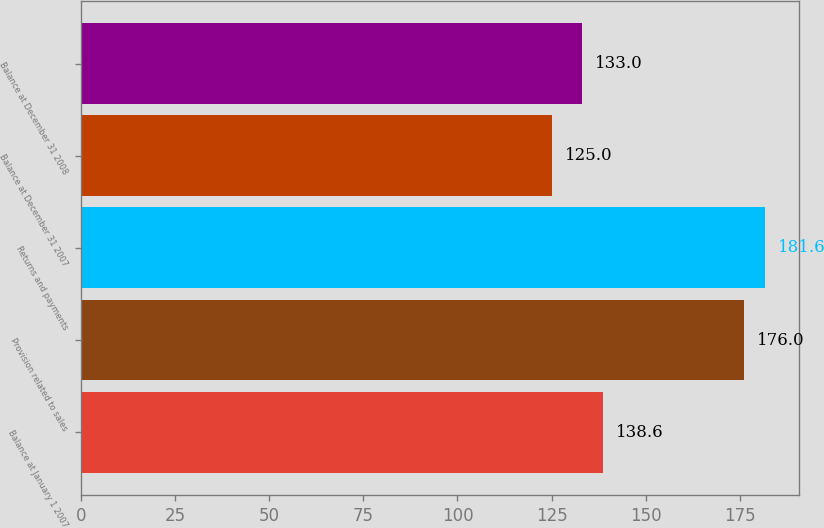Convert chart. <chart><loc_0><loc_0><loc_500><loc_500><bar_chart><fcel>Balance at January 1 2007<fcel>Provision related to sales<fcel>Returns and payments<fcel>Balance at December 31 2007<fcel>Balance at December 31 2008<nl><fcel>138.6<fcel>176<fcel>181.6<fcel>125<fcel>133<nl></chart> 